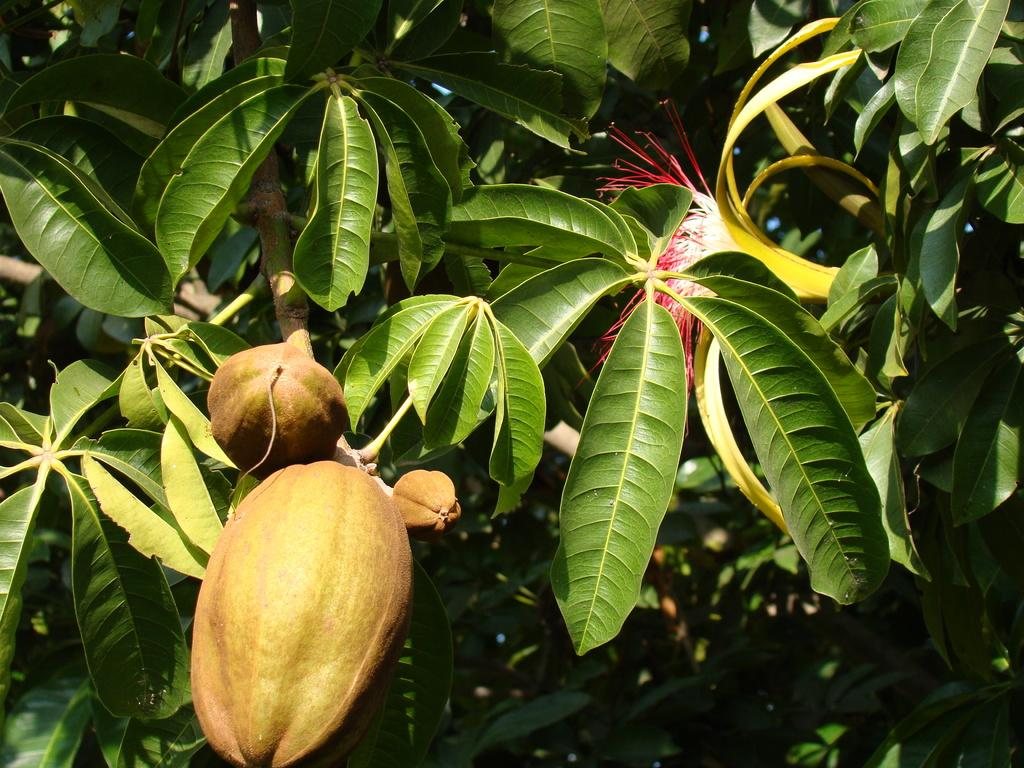What type of vegetation is visible in the image? There are trees in the image. What type of food items can be seen in the image? There are fruits in the image. What type of plant is present in the image? There is a flower in the image. How many babies are visible in the image? There are no babies present in the image. What type of substance is being used to create the flower in the image? The image does not provide information about the substance used to create the flower. 